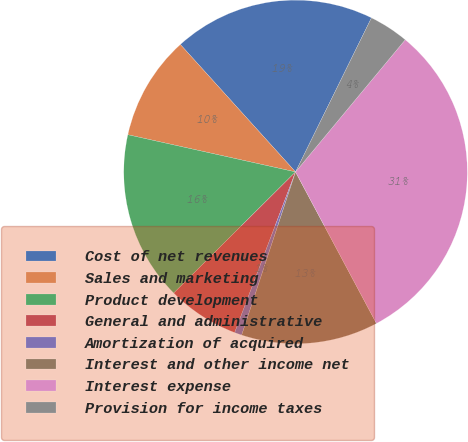Convert chart. <chart><loc_0><loc_0><loc_500><loc_500><pie_chart><fcel>Cost of net revenues<fcel>Sales and marketing<fcel>Product development<fcel>General and administrative<fcel>Amortization of acquired<fcel>Interest and other income net<fcel>Interest expense<fcel>Provision for income taxes<nl><fcel>18.98%<fcel>9.83%<fcel>15.93%<fcel>6.78%<fcel>0.69%<fcel>12.88%<fcel>31.17%<fcel>3.74%<nl></chart> 